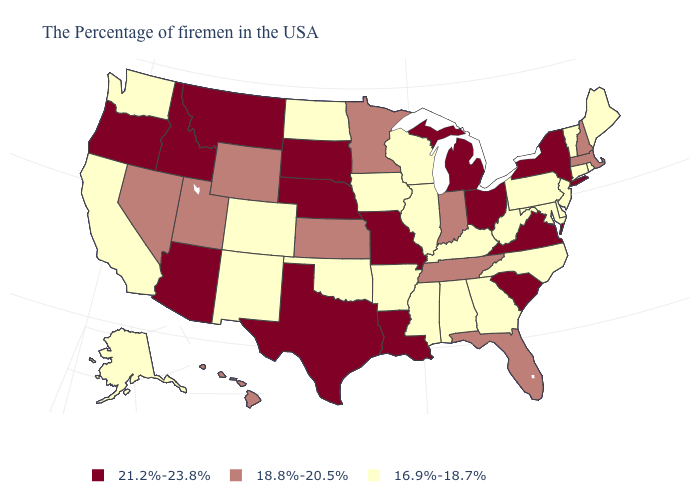Among the states that border New Hampshire , does Maine have the lowest value?
Write a very short answer. Yes. Which states have the lowest value in the South?
Answer briefly. Delaware, Maryland, North Carolina, West Virginia, Georgia, Kentucky, Alabama, Mississippi, Arkansas, Oklahoma. Which states have the highest value in the USA?
Be succinct. New York, Virginia, South Carolina, Ohio, Michigan, Louisiana, Missouri, Nebraska, Texas, South Dakota, Montana, Arizona, Idaho, Oregon. What is the highest value in the MidWest ?
Concise answer only. 21.2%-23.8%. What is the highest value in the Northeast ?
Short answer required. 21.2%-23.8%. What is the value of Mississippi?
Short answer required. 16.9%-18.7%. Name the states that have a value in the range 21.2%-23.8%?
Short answer required. New York, Virginia, South Carolina, Ohio, Michigan, Louisiana, Missouri, Nebraska, Texas, South Dakota, Montana, Arizona, Idaho, Oregon. Name the states that have a value in the range 18.8%-20.5%?
Quick response, please. Massachusetts, New Hampshire, Florida, Indiana, Tennessee, Minnesota, Kansas, Wyoming, Utah, Nevada, Hawaii. How many symbols are there in the legend?
Be succinct. 3. Does Alabama have the lowest value in the South?
Write a very short answer. Yes. What is the value of South Dakota?
Be succinct. 21.2%-23.8%. Name the states that have a value in the range 21.2%-23.8%?
Concise answer only. New York, Virginia, South Carolina, Ohio, Michigan, Louisiana, Missouri, Nebraska, Texas, South Dakota, Montana, Arizona, Idaho, Oregon. Does Texas have the highest value in the South?
Write a very short answer. Yes. Does Missouri have a higher value than Florida?
Answer briefly. Yes. Does the map have missing data?
Give a very brief answer. No. 